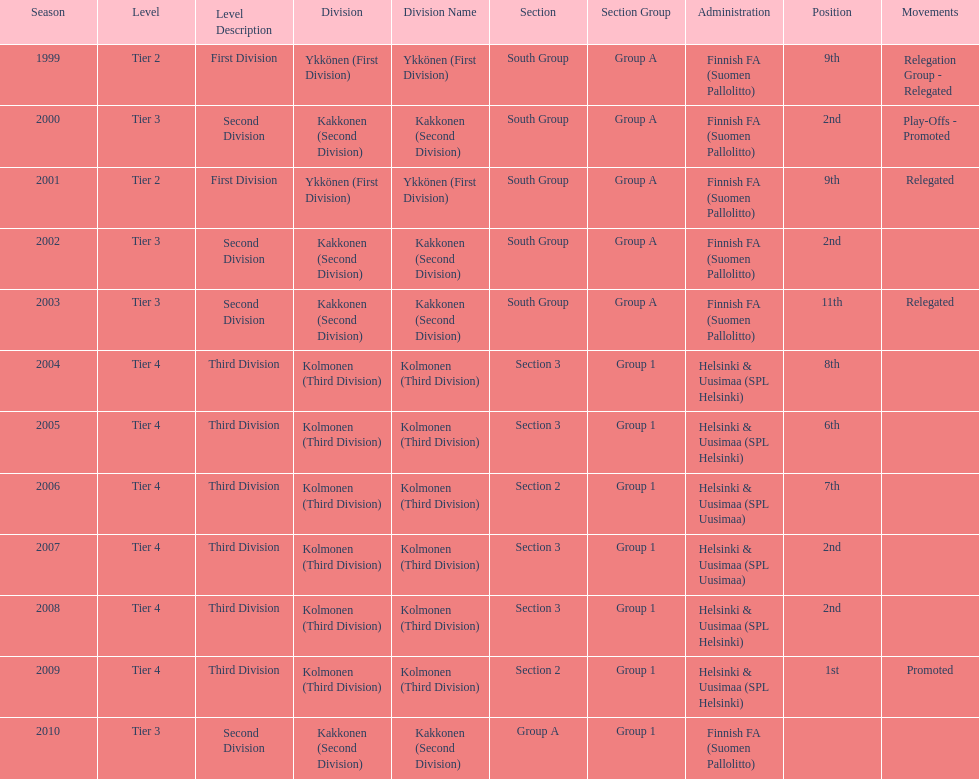How many times were they in tier 3? 4. Parse the table in full. {'header': ['Season', 'Level', 'Level Description', 'Division', 'Division Name', 'Section', 'Section Group', 'Administration', 'Position', 'Movements'], 'rows': [['1999', 'Tier 2', 'First Division', 'Ykkönen (First Division)', 'Ykkönen (First Division)', 'South Group', 'Group A', 'Finnish FA (Suomen Pallolitto)', '9th', 'Relegation Group - Relegated'], ['2000', 'Tier 3', 'Second Division', 'Kakkonen (Second Division)', 'Kakkonen (Second Division)', 'South Group', 'Group A', 'Finnish FA (Suomen Pallolitto)', '2nd', 'Play-Offs - Promoted'], ['2001', 'Tier 2', 'First Division', 'Ykkönen (First Division)', 'Ykkönen (First Division)', 'South Group', 'Group A', 'Finnish FA (Suomen Pallolitto)', '9th', 'Relegated'], ['2002', 'Tier 3', 'Second Division', 'Kakkonen (Second Division)', 'Kakkonen (Second Division)', 'South Group', 'Group A', 'Finnish FA (Suomen Pallolitto)', '2nd', ''], ['2003', 'Tier 3', 'Second Division', 'Kakkonen (Second Division)', 'Kakkonen (Second Division)', 'South Group', 'Group A', 'Finnish FA (Suomen Pallolitto)', '11th', 'Relegated'], ['2004', 'Tier 4', 'Third Division', 'Kolmonen (Third Division)', 'Kolmonen (Third Division)', 'Section 3', 'Group 1', 'Helsinki & Uusimaa (SPL Helsinki)', '8th', ''], ['2005', 'Tier 4', 'Third Division', 'Kolmonen (Third Division)', 'Kolmonen (Third Division)', 'Section 3', 'Group 1', 'Helsinki & Uusimaa (SPL Helsinki)', '6th', ''], ['2006', 'Tier 4', 'Third Division', 'Kolmonen (Third Division)', 'Kolmonen (Third Division)', 'Section 2', 'Group 1', 'Helsinki & Uusimaa (SPL Uusimaa)', '7th', ''], ['2007', 'Tier 4', 'Third Division', 'Kolmonen (Third Division)', 'Kolmonen (Third Division)', 'Section 3', 'Group 1', 'Helsinki & Uusimaa (SPL Uusimaa)', '2nd', ''], ['2008', 'Tier 4', 'Third Division', 'Kolmonen (Third Division)', 'Kolmonen (Third Division)', 'Section 3', 'Group 1', 'Helsinki & Uusimaa (SPL Helsinki)', '2nd', ''], ['2009', 'Tier 4', 'Third Division', 'Kolmonen (Third Division)', 'Kolmonen (Third Division)', 'Section 2', 'Group 1', 'Helsinki & Uusimaa (SPL Helsinki)', '1st', 'Promoted'], ['2010', 'Tier 3', 'Second Division', 'Kakkonen (Second Division)', 'Kakkonen (Second Division)', 'Group A', 'Group 1', 'Finnish FA (Suomen Pallolitto)', '', '']]} 